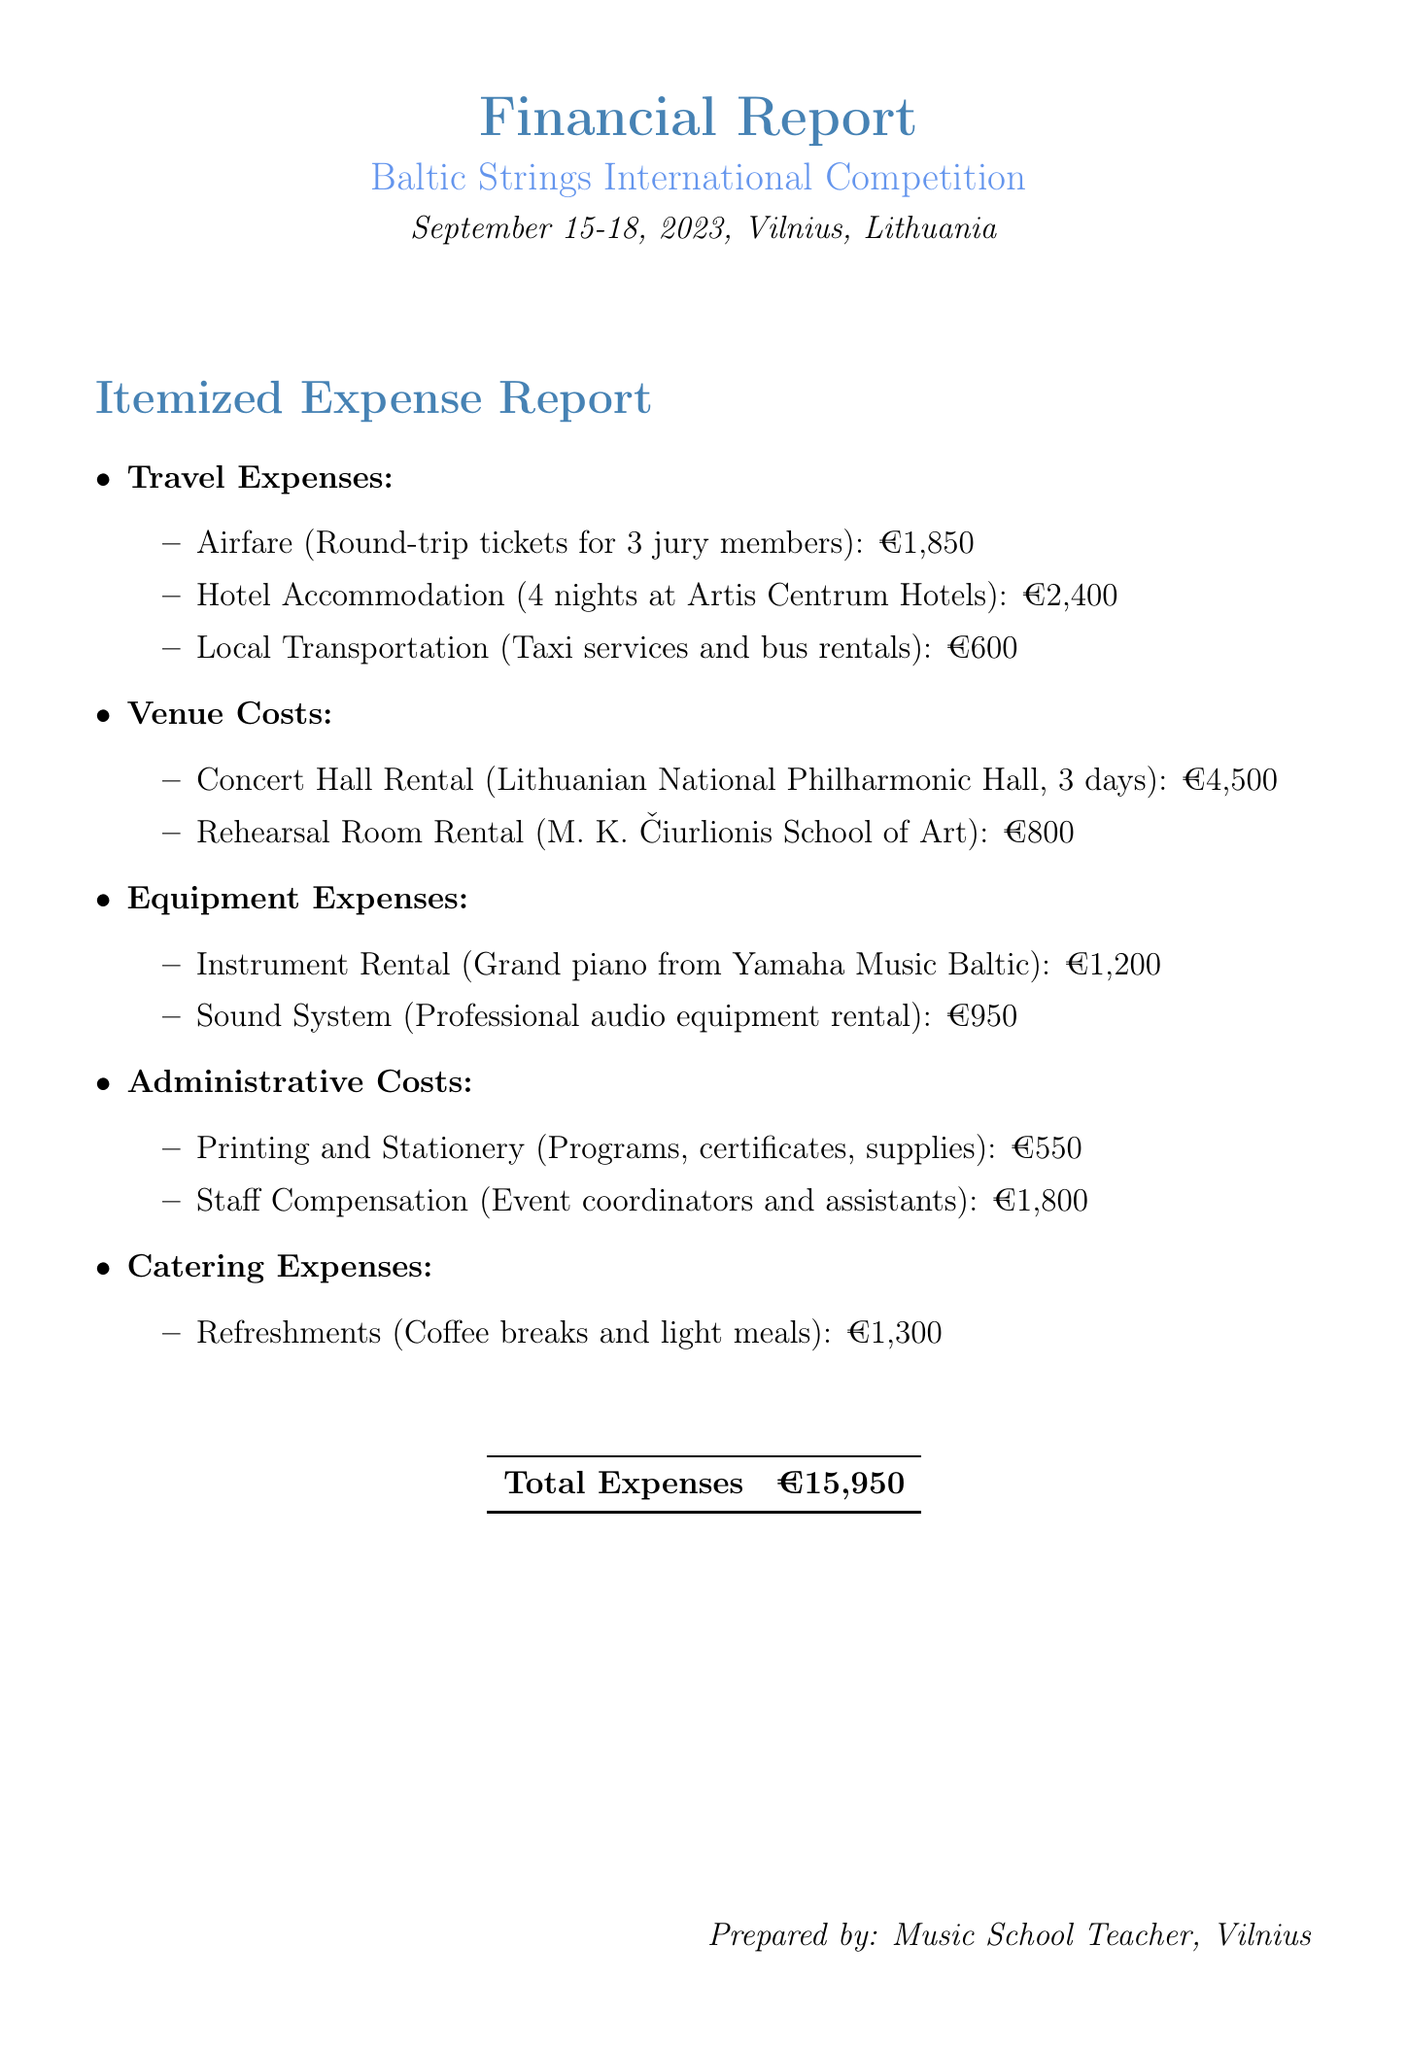What is the name of the event? The document states the event name in the title section, which is the Baltic Strings International Competition.
Answer: Baltic Strings International Competition What are the dates of the competition? The event dates are mentioned clearly in the document, which are September 15-18, 2023.
Answer: September 15-18, 2023 How much was spent on hotel accommodation? The itemized travel expenses list the hotel accommodation cost as €2,400 for 4 nights.
Answer: €2,400 What is the total amount of venue costs? Venue costs are itemized, adding up €4,500 for the concert hall rental and €800 for the rehearsal room rental, giving a total of €5,300.
Answer: €5,300 What was the amount allocated for refreshments during the event? The document specifies that refreshments cost €1,300 in the catering expenses section.
Answer: €1,300 How many jury members traveled by air? The airfare expense specifies that round-trip tickets were purchased for 3 jury members.
Answer: 3 What is the total expense reported in the document? The total expenses are summarized clearly at the end of the report as €15,950.
Answer: €15,950 Which company provided the grand piano for the event? The document mentions that the grand piano was rented from Yamaha Music Baltic.
Answer: Yamaha Music Baltic What type of costs are included in administrative costs? The administrative costs include printing and stationery, and staff compensation, as detailed in the report.
Answer: Printing and Stationery, Staff Compensation 